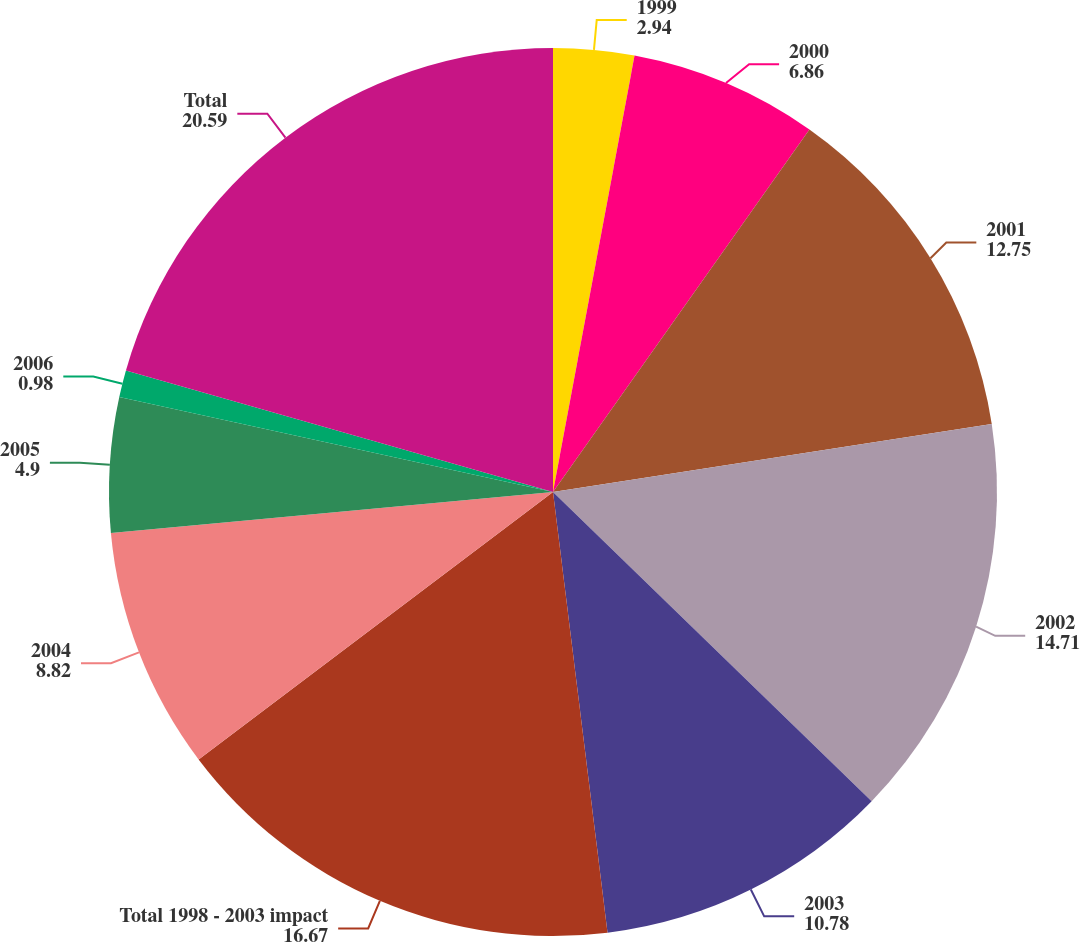<chart> <loc_0><loc_0><loc_500><loc_500><pie_chart><fcel>1999<fcel>2000<fcel>2001<fcel>2002<fcel>2003<fcel>Total 1998 - 2003 impact<fcel>2004<fcel>2005<fcel>2006<fcel>Total<nl><fcel>2.94%<fcel>6.86%<fcel>12.75%<fcel>14.71%<fcel>10.78%<fcel>16.67%<fcel>8.82%<fcel>4.9%<fcel>0.98%<fcel>20.59%<nl></chart> 